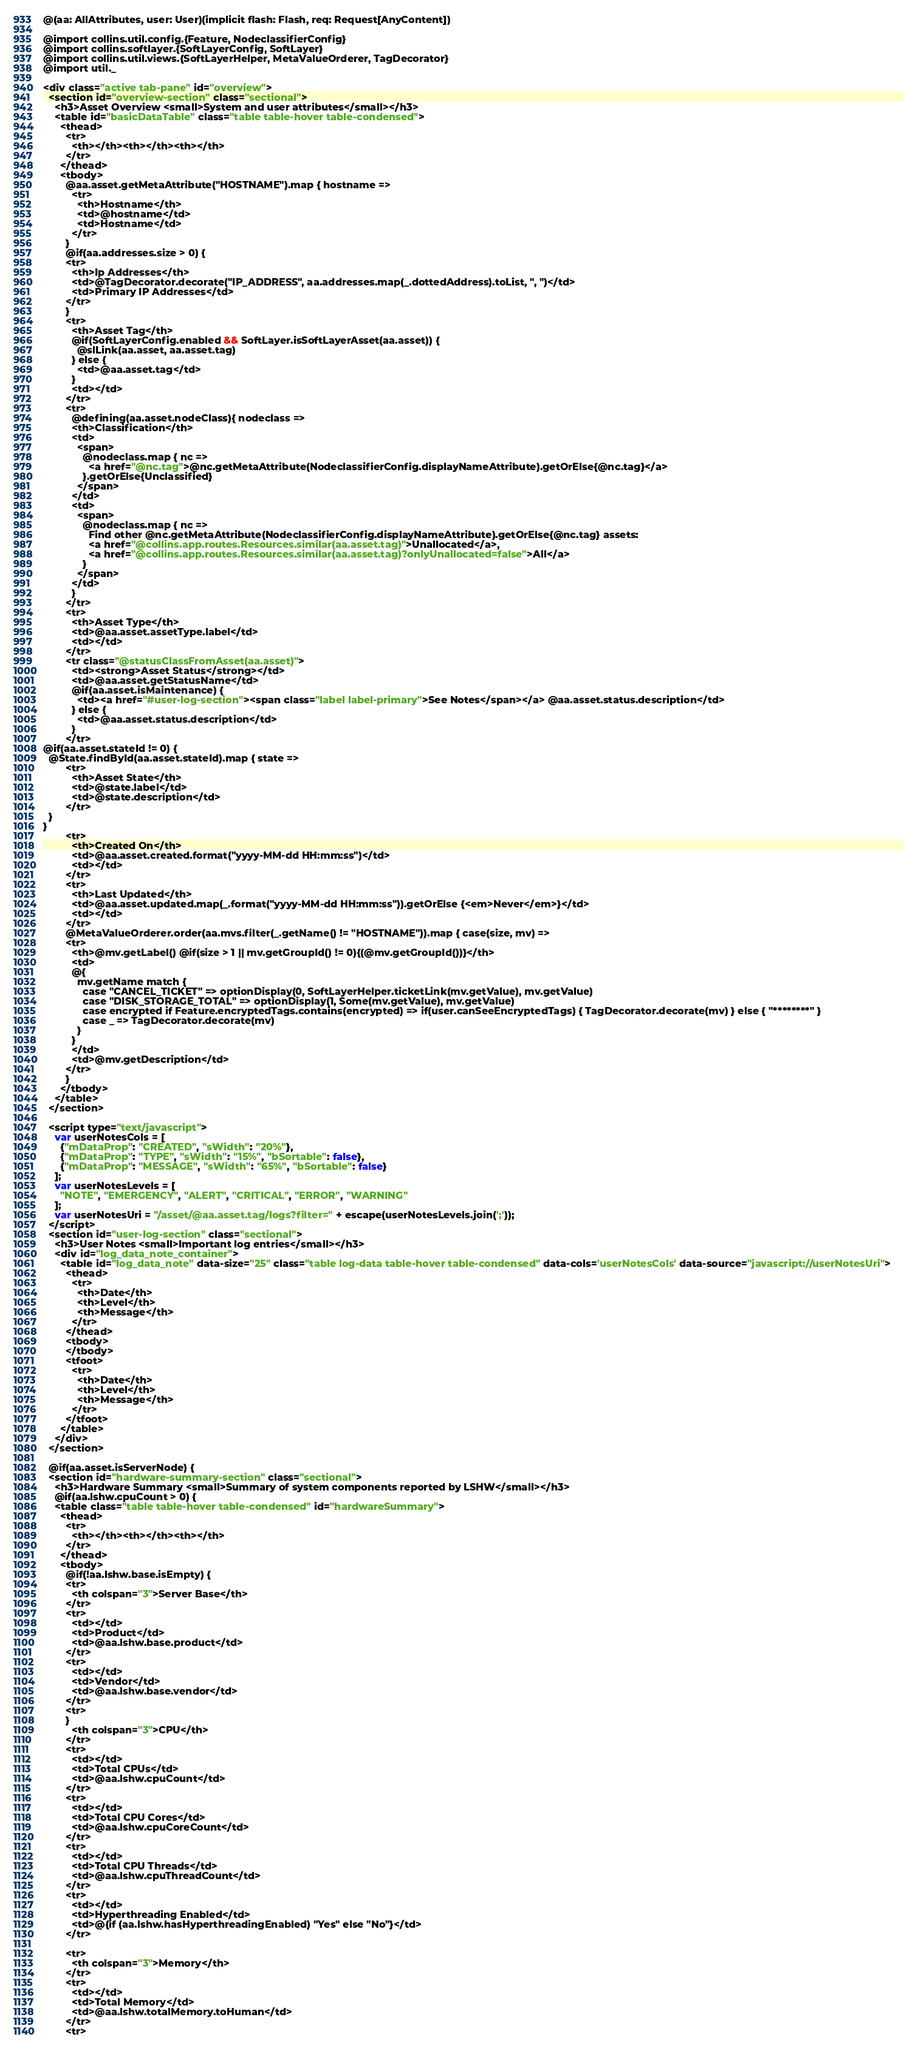Convert code to text. <code><loc_0><loc_0><loc_500><loc_500><_HTML_>@(aa: AllAttributes, user: User)(implicit flash: Flash, req: Request[AnyContent])

@import collins.util.config.{Feature, NodeclassifierConfig}
@import collins.softlayer.{SoftLayerConfig, SoftLayer}
@import collins.util.views.{SoftLayerHelper, MetaValueOrderer, TagDecorator}
@import util._

<div class="active tab-pane" id="overview">
  <section id="overview-section" class="sectional">
    <h3>Asset Overview <small>System and user attributes</small></h3>
    <table id="basicDataTable" class="table table-hover table-condensed">
      <thead>
        <tr>
          <th></th><th></th><th></th>
        </tr>
      </thead>
      <tbody>
        @aa.asset.getMetaAttribute("HOSTNAME").map { hostname =>
          <tr>
            <th>Hostname</th>
            <td>@hostname</td>
            <td>Hostname</td>
          </tr>
        }
        @if(aa.addresses.size > 0) {
        <tr>
          <th>Ip Addresses</th>
          <td>@TagDecorator.decorate("IP_ADDRESS", aa.addresses.map(_.dottedAddress).toList, ", ")</td>
          <td>Primary IP Addresses</td>
        </tr>
        }
        <tr>
          <th>Asset Tag</th>
          @if(SoftLayerConfig.enabled && SoftLayer.isSoftLayerAsset(aa.asset)) {
            @slLink(aa.asset, aa.asset.tag)
          } else {
            <td>@aa.asset.tag</td>
          }
          <td></td>
        </tr>
        <tr>
          @defining(aa.asset.nodeClass){ nodeclass =>
          <th>Classification</th>
          <td>
            <span>
              @nodeclass.map { nc =>
                <a href="@nc.tag">@nc.getMetaAttribute(NodeclassifierConfig.displayNameAttribute).getOrElse{@nc.tag}</a>
              }.getOrElse{Unclassified}
            </span>
          </td>
          <td>
            <span>
              @nodeclass.map { nc =>
                Find other @nc.getMetaAttribute(NodeclassifierConfig.displayNameAttribute).getOrElse{@nc.tag} assets:
                <a href="@collins.app.routes.Resources.similar(aa.asset.tag)">Unallocated</a>,
                <a href="@collins.app.routes.Resources.similar(aa.asset.tag)?onlyUnallocated=false">All</a>
              }
            </span>
          </td>
          }
        </tr>
        <tr>
          <th>Asset Type</th>
          <td>@aa.asset.assetType.label</td>
          <td></td>
        </tr>
        <tr class="@statusClassFromAsset(aa.asset)">
          <td><strong>Asset Status</strong></td>
          <td>@aa.asset.getStatusName</td>
          @if(aa.asset.isMaintenance) {
            <td><a href="#user-log-section"><span class="label label-primary">See Notes</span></a> @aa.asset.status.description</td>
          } else {
            <td>@aa.asset.status.description</td>
          }
        </tr>
@if(aa.asset.stateId != 0) {
  @State.findById(aa.asset.stateId).map { state =>
        <tr>
          <th>Asset State</th>
          <td>@state.label</td>
          <td>@state.description</td>
        </tr>
  }
}
        <tr>
          <th>Created On</th>
          <td>@aa.asset.created.format("yyyy-MM-dd HH:mm:ss")</td>
          <td></td>
        </tr>
        <tr>
          <th>Last Updated</th>
          <td>@aa.asset.updated.map(_.format("yyyy-MM-dd HH:mm:ss")).getOrElse {<em>Never</em>}</td>
          <td></td>
        </tr>
        @MetaValueOrderer.order(aa.mvs.filter(_.getName() != "HOSTNAME")).map { case(size, mv) =>
        <tr>
          <th>@mv.getLabel() @if(size > 1 || mv.getGroupId() != 0){(@mv.getGroupId())}</th>
          <td>
          @{
            mv.getName match {
              case "CANCEL_TICKET" => optionDisplay(0, SoftLayerHelper.ticketLink(mv.getValue), mv.getValue)
              case "DISK_STORAGE_TOTAL" => optionDisplay(1, Some(mv.getValue), mv.getValue)
              case encrypted if Feature.encryptedTags.contains(encrypted) => if(user.canSeeEncryptedTags) { TagDecorator.decorate(mv) } else { "********" }
              case _ => TagDecorator.decorate(mv)
            }
          }
          </td>
          <td>@mv.getDescription</td>
        </tr>
        }
      </tbody>
    </table>
  </section>

  <script type="text/javascript">
    var userNotesCols = [
      {"mDataProp": "CREATED", "sWidth": "20%"},
      {"mDataProp": "TYPE", "sWidth": "15%", "bSortable": false},
      {"mDataProp": "MESSAGE", "sWidth": "65%", "bSortable": false}
    ];
    var userNotesLevels = [
      "NOTE", "EMERGENCY", "ALERT", "CRITICAL", "ERROR", "WARNING"
    ];
    var userNotesUri = "/asset/@aa.asset.tag/logs?filter=" + escape(userNotesLevels.join(';'));
  </script>
  <section id="user-log-section" class="sectional">
    <h3>User Notes <small>Important log entries</small></h3>
    <div id="log_data_note_container">
      <table id="log_data_note" data-size="25" class="table log-data table-hover table-condensed" data-cols='userNotesCols' data-source="javascript://userNotesUri">
        <thead>
          <tr>
            <th>Date</th>
            <th>Level</th>
            <th>Message</th>
          </tr>
        </thead>
        <tbody>
        </tbody>
        <tfoot>
          <tr>
            <th>Date</th>
            <th>Level</th>
            <th>Message</th>
          </tr>
        </tfoot>
      </table>
    </div>
  </section>

  @if(aa.asset.isServerNode) {
  <section id="hardware-summary-section" class="sectional">
    <h3>Hardware Summary <small>Summary of system components reported by LSHW</small></h3>
    @if(aa.lshw.cpuCount > 0) {
    <table class="table table-hover table-condensed" id="hardwareSummary">
      <thead>
        <tr>
          <th></th><th></th><th></th>
        </tr>
      </thead>
      <tbody>
        @if(!aa.lshw.base.isEmpty) {
        <tr>
          <th colspan="3">Server Base</th>
        </tr>
        <tr>
          <td></td>
          <td>Product</td>
          <td>@aa.lshw.base.product</td>
        </tr>
        <tr>
          <td></td>
          <td>Vendor</td>
          <td>@aa.lshw.base.vendor</td>
        </tr>
        <tr>
        }
          <th colspan="3">CPU</th>
        </tr>
        <tr>
          <td></td>
          <td>Total CPUs</td>
          <td>@aa.lshw.cpuCount</td>
        </tr>
        <tr>
          <td></td>
          <td>Total CPU Cores</td>
          <td>@aa.lshw.cpuCoreCount</td>
        </tr>
        <tr>
          <td></td>
          <td>Total CPU Threads</td>
          <td>@aa.lshw.cpuThreadCount</td>
        </tr>
        <tr>
          <td></td>
          <td>Hyperthreading Enabled</td>
          <td>@{if (aa.lshw.hasHyperthreadingEnabled) "Yes" else "No"}</td>
        </tr>

        <tr>
          <th colspan="3">Memory</th>
        </tr>
        <tr>
          <td></td>
          <td>Total Memory</td>
          <td>@aa.lshw.totalMemory.toHuman</td>
        </tr>
        <tr></code> 